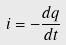Convert formula to latex. <formula><loc_0><loc_0><loc_500><loc_500>i = - \frac { d q } { d t }</formula> 